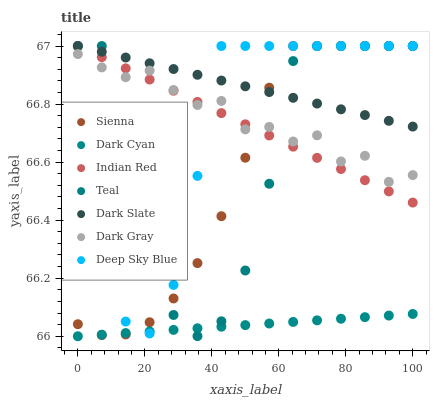Does Dark Cyan have the minimum area under the curve?
Answer yes or no. Yes. Does Dark Slate have the maximum area under the curve?
Answer yes or no. Yes. Does Indian Red have the minimum area under the curve?
Answer yes or no. No. Does Indian Red have the maximum area under the curve?
Answer yes or no. No. Is Indian Red the smoothest?
Answer yes or no. Yes. Is Teal the roughest?
Answer yes or no. Yes. Is Sienna the smoothest?
Answer yes or no. No. Is Sienna the roughest?
Answer yes or no. No. Does Dark Cyan have the lowest value?
Answer yes or no. Yes. Does Indian Red have the lowest value?
Answer yes or no. No. Does Deep Sky Blue have the highest value?
Answer yes or no. Yes. Does Dark Cyan have the highest value?
Answer yes or no. No. Is Dark Cyan less than Indian Red?
Answer yes or no. Yes. Is Dark Gray greater than Dark Cyan?
Answer yes or no. Yes. Does Indian Red intersect Deep Sky Blue?
Answer yes or no. Yes. Is Indian Red less than Deep Sky Blue?
Answer yes or no. No. Is Indian Red greater than Deep Sky Blue?
Answer yes or no. No. Does Dark Cyan intersect Indian Red?
Answer yes or no. No. 